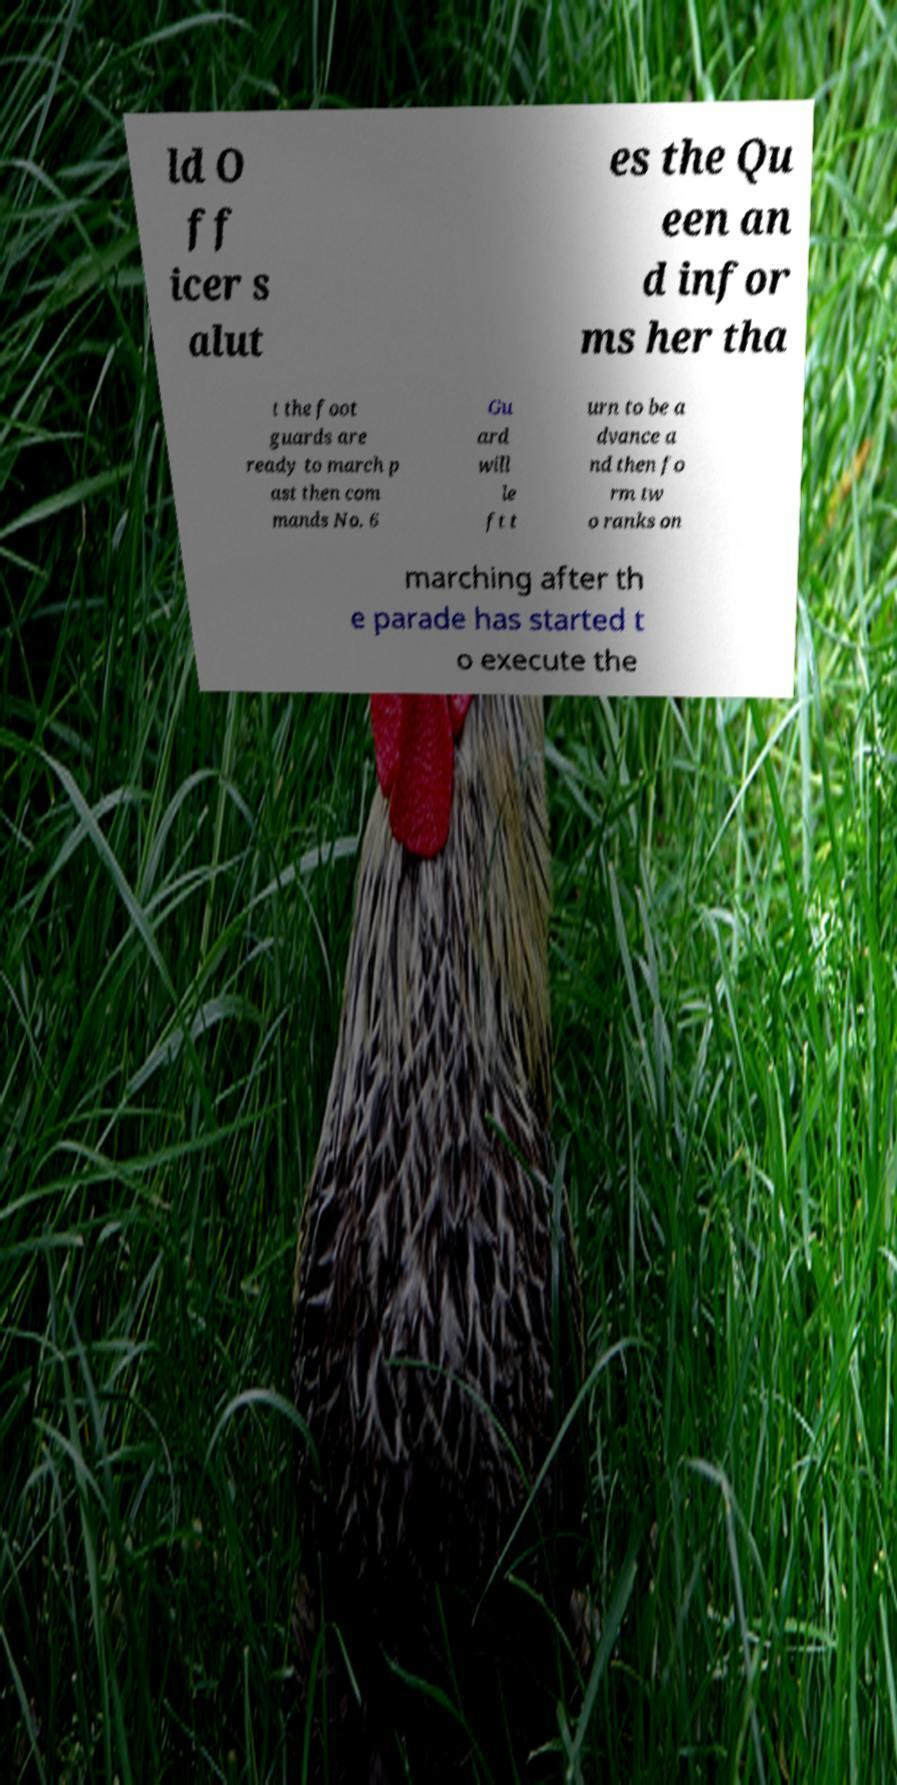Please identify and transcribe the text found in this image. ld O ff icer s alut es the Qu een an d infor ms her tha t the foot guards are ready to march p ast then com mands No. 6 Gu ard will le ft t urn to be a dvance a nd then fo rm tw o ranks on marching after th e parade has started t o execute the 